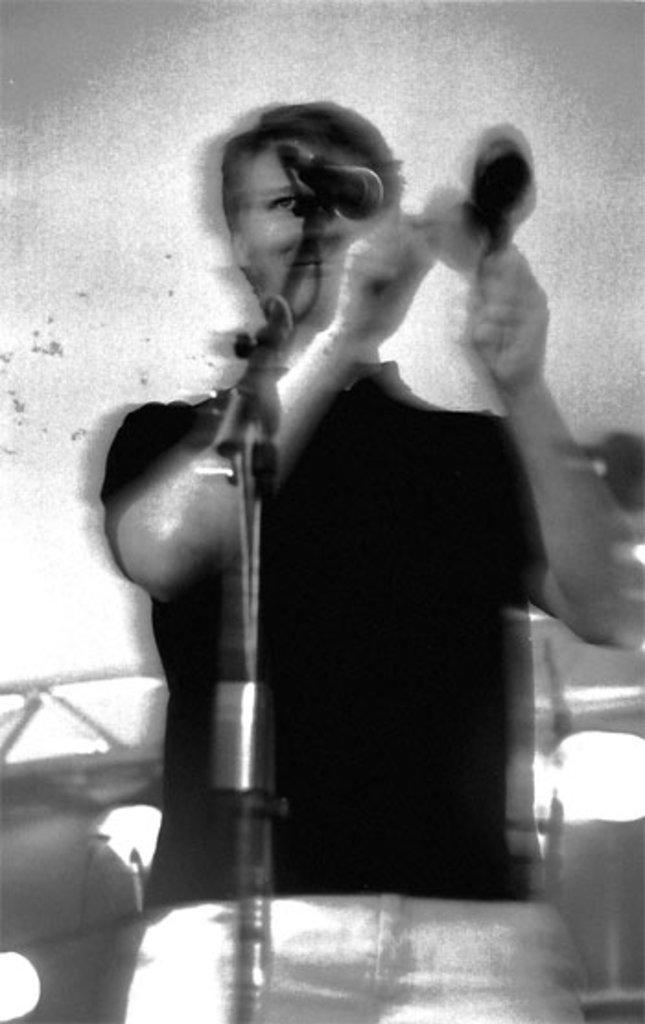What is the color scheme of the image? The image is black and white. Can you describe the person in the image? There is a man standing in the image. What is the man holding in his hands? The man is holding a microphone in his hands. How is the microphone positioned in the image? The microphone is attached to a stand. Is the man sinking in quicksand in the image? No, there is no quicksand present in the image. How many centimeters does the man's digestion process take in the image? The image does not provide any information about the man's digestion process. 